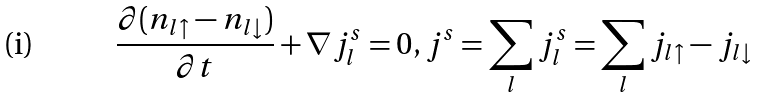Convert formula to latex. <formula><loc_0><loc_0><loc_500><loc_500>\frac { \partial ( n _ { l \uparrow } - n _ { l \downarrow } ) } { \partial t } + \nabla j ^ { s } _ { l } = 0 , j ^ { s } = \sum _ { l } j ^ { s } _ { l } = \sum _ { l } j _ { l \uparrow } - j _ { l \downarrow }</formula> 